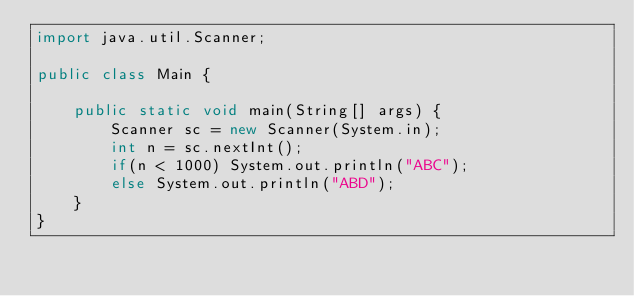Convert code to text. <code><loc_0><loc_0><loc_500><loc_500><_Java_>import java.util.Scanner;

public class Main {

    public static void main(String[] args) {
        Scanner sc = new Scanner(System.in);
        int n = sc.nextInt();
        if(n < 1000) System.out.println("ABC");
        else System.out.println("ABD");
    }
}</code> 